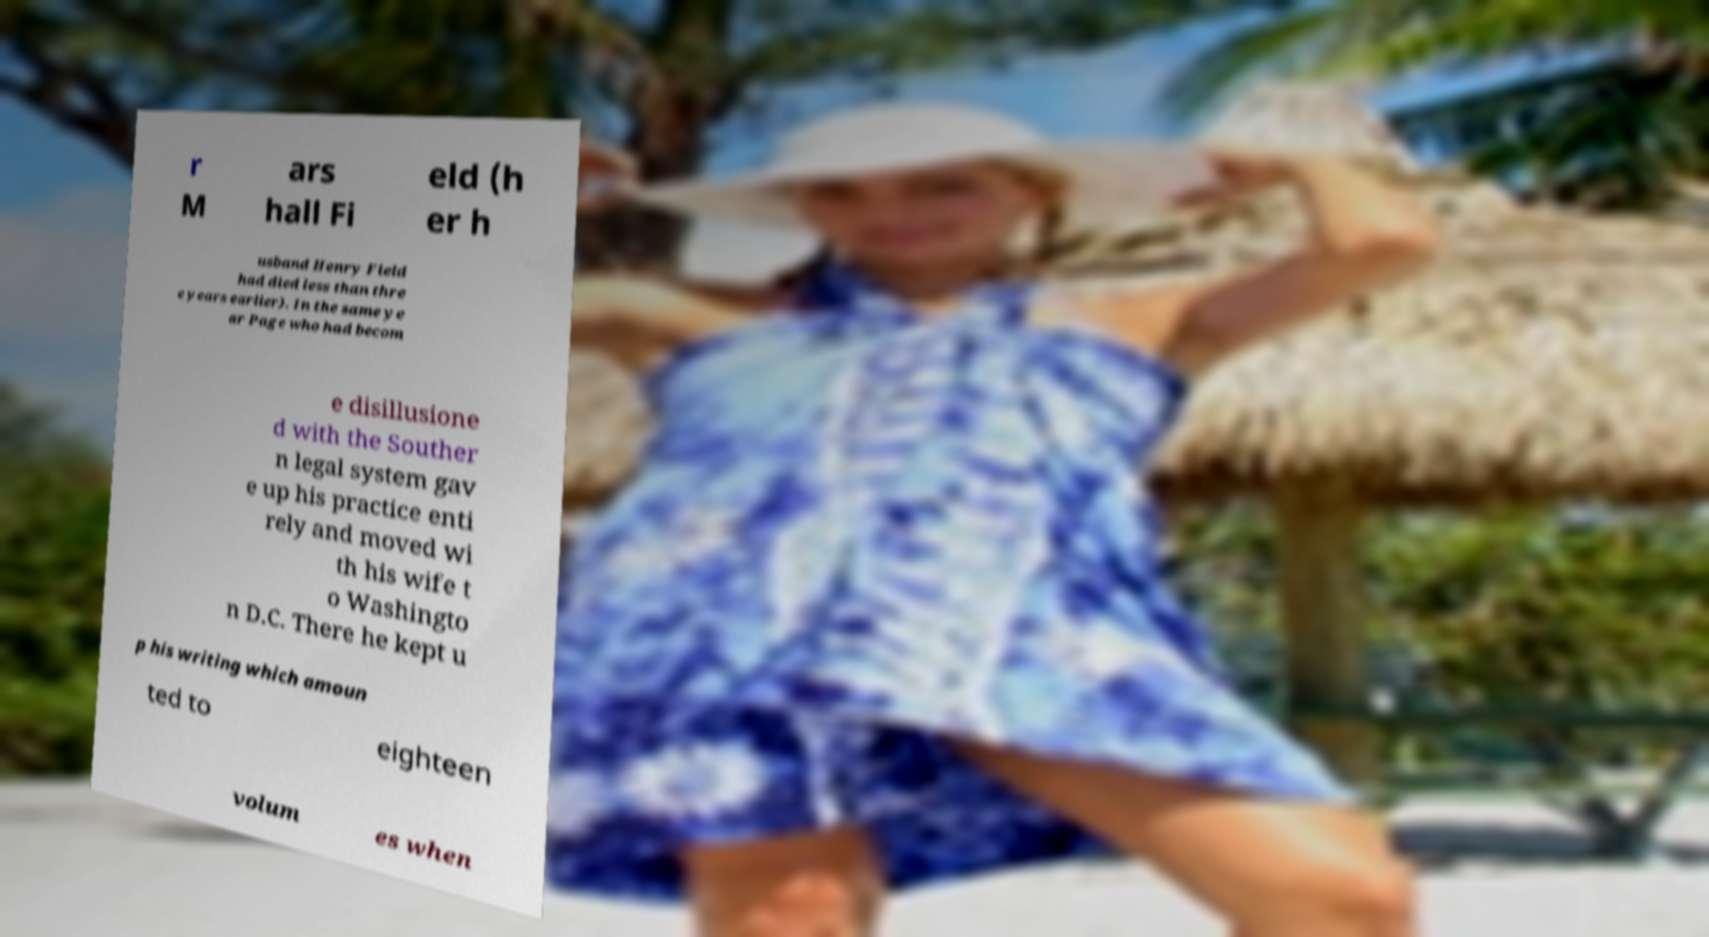Could you extract and type out the text from this image? r M ars hall Fi eld (h er h usband Henry Field had died less than thre e years earlier). In the same ye ar Page who had becom e disillusione d with the Souther n legal system gav e up his practice enti rely and moved wi th his wife t o Washingto n D.C. There he kept u p his writing which amoun ted to eighteen volum es when 